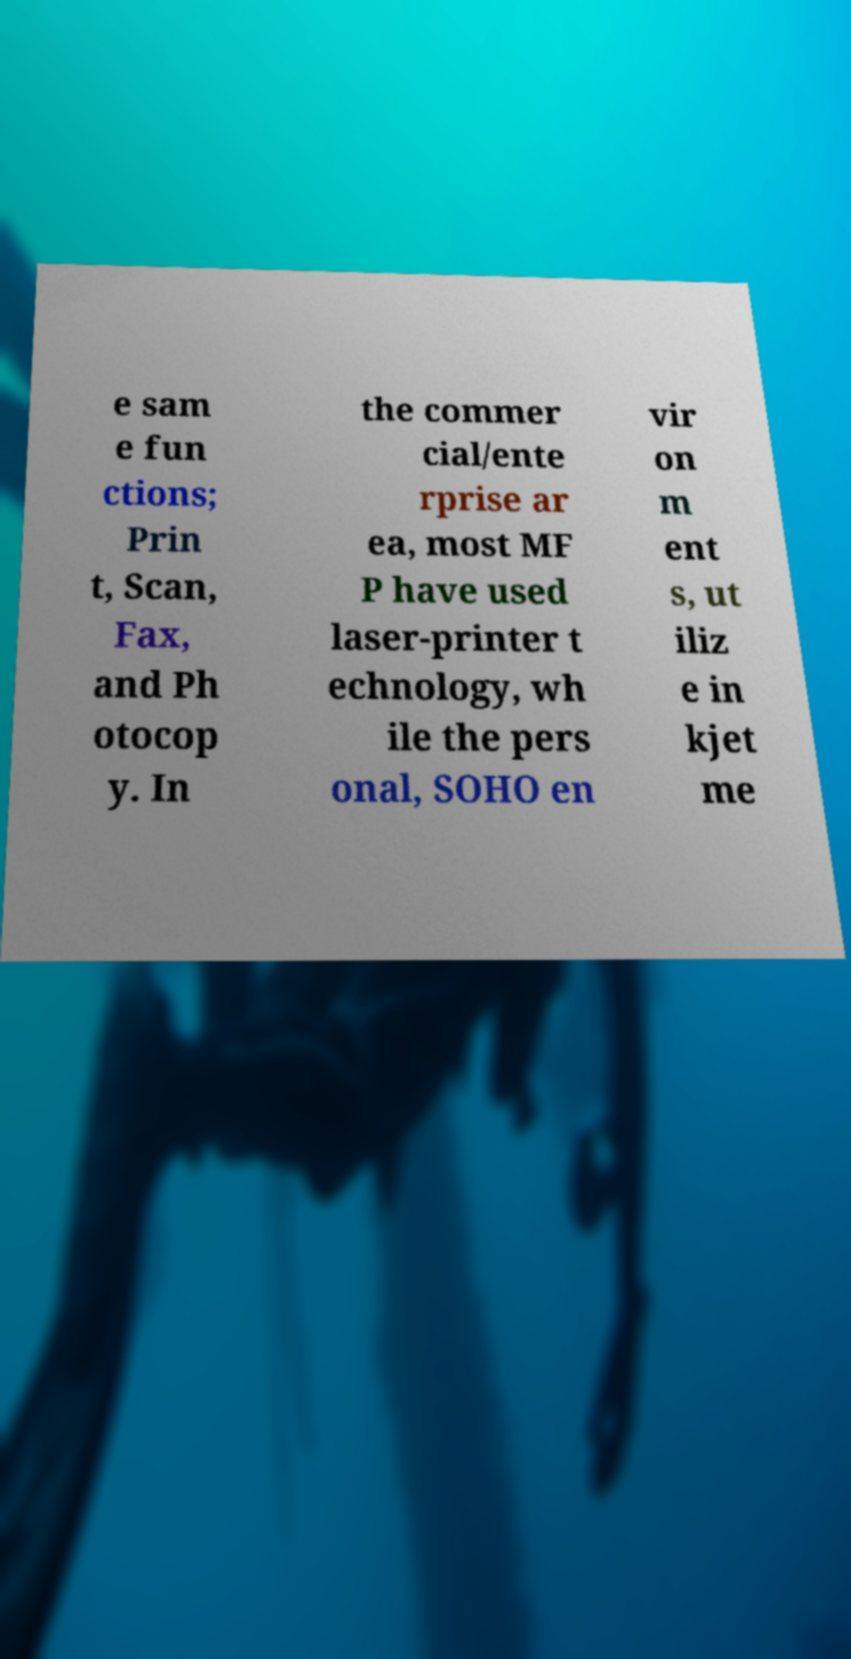Could you assist in decoding the text presented in this image and type it out clearly? e sam e fun ctions; Prin t, Scan, Fax, and Ph otocop y. In the commer cial/ente rprise ar ea, most MF P have used laser-printer t echnology, wh ile the pers onal, SOHO en vir on m ent s, ut iliz e in kjet me 